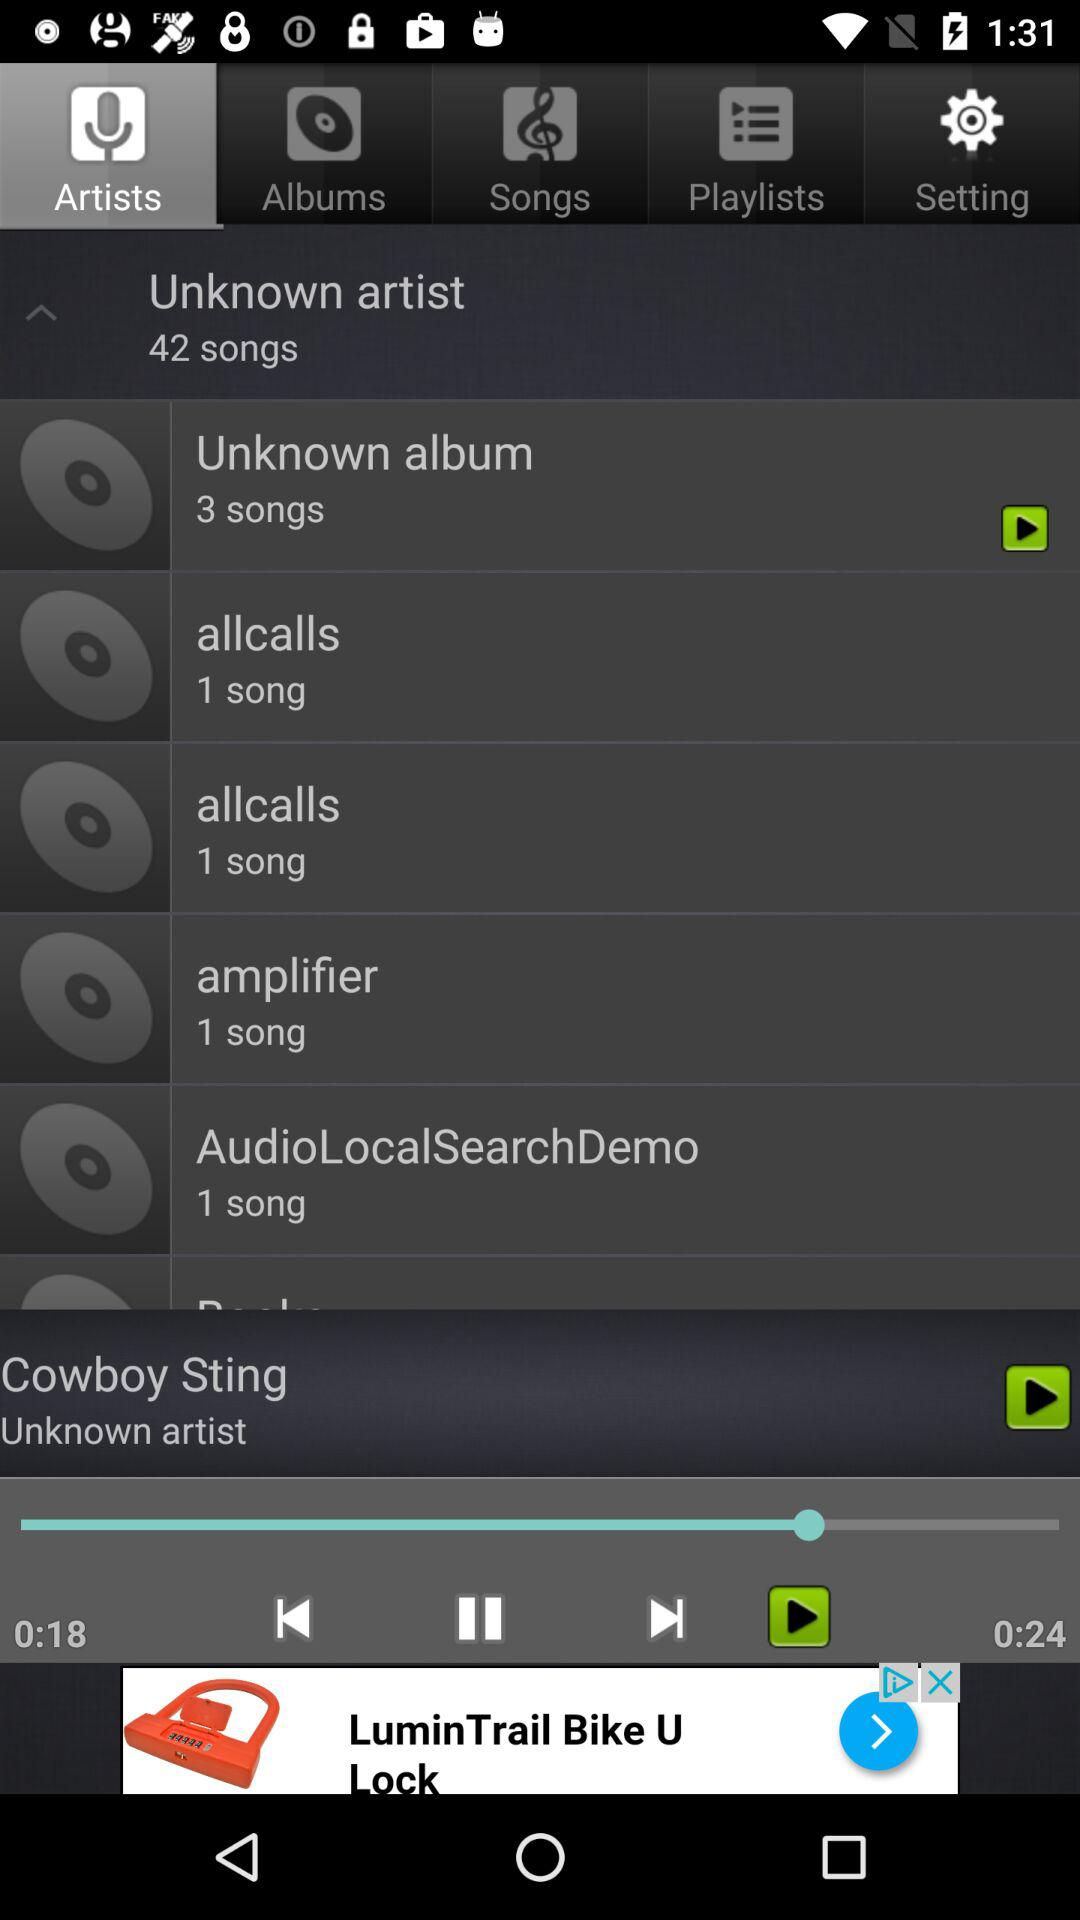Which tab is selected? The selected tab is artists. 